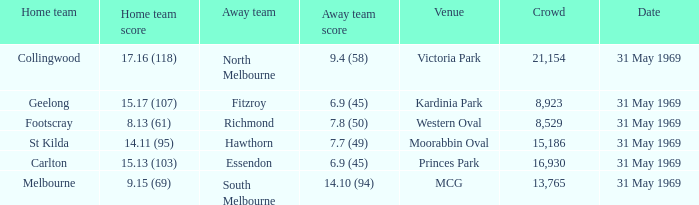Who was the home team in the game where North Melbourne was the away team? 17.16 (118). 